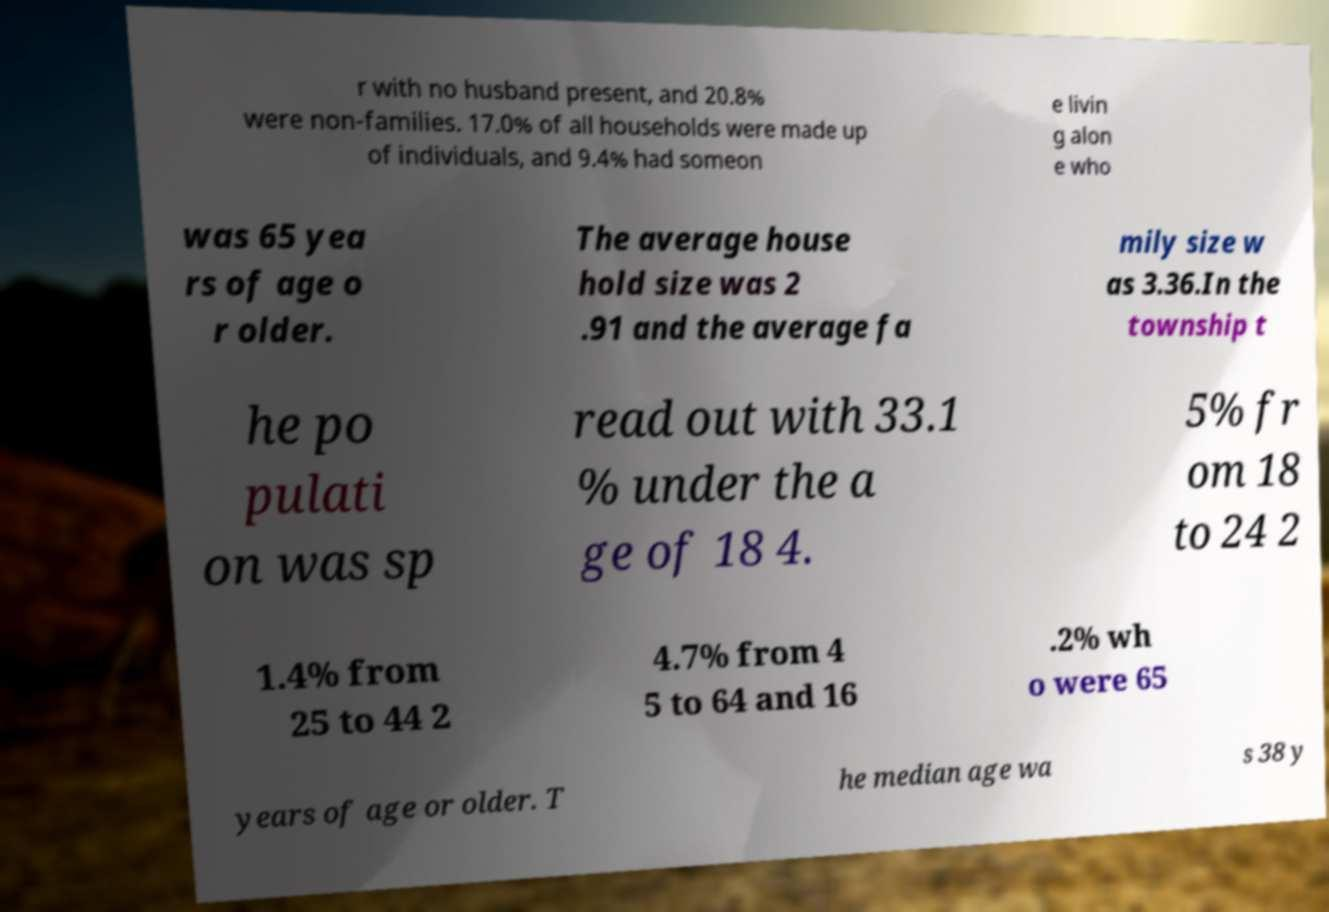Please read and relay the text visible in this image. What does it say? r with no husband present, and 20.8% were non-families. 17.0% of all households were made up of individuals, and 9.4% had someon e livin g alon e who was 65 yea rs of age o r older. The average house hold size was 2 .91 and the average fa mily size w as 3.36.In the township t he po pulati on was sp read out with 33.1 % under the a ge of 18 4. 5% fr om 18 to 24 2 1.4% from 25 to 44 2 4.7% from 4 5 to 64 and 16 .2% wh o were 65 years of age or older. T he median age wa s 38 y 